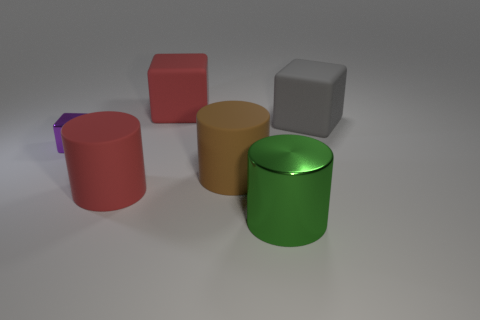Subtract all large rubber cylinders. How many cylinders are left? 1 Subtract all brown cylinders. How many cylinders are left? 2 Add 3 tiny metallic blocks. How many objects exist? 9 Add 1 big green shiny cylinders. How many big green shiny cylinders are left? 2 Add 3 big metal cylinders. How many big metal cylinders exist? 4 Subtract 0 cyan balls. How many objects are left? 6 Subtract 3 cubes. How many cubes are left? 0 Subtract all gray cylinders. Subtract all green cubes. How many cylinders are left? 3 Subtract all cyan balls. How many brown cylinders are left? 1 Subtract all green rubber spheres. Subtract all tiny things. How many objects are left? 5 